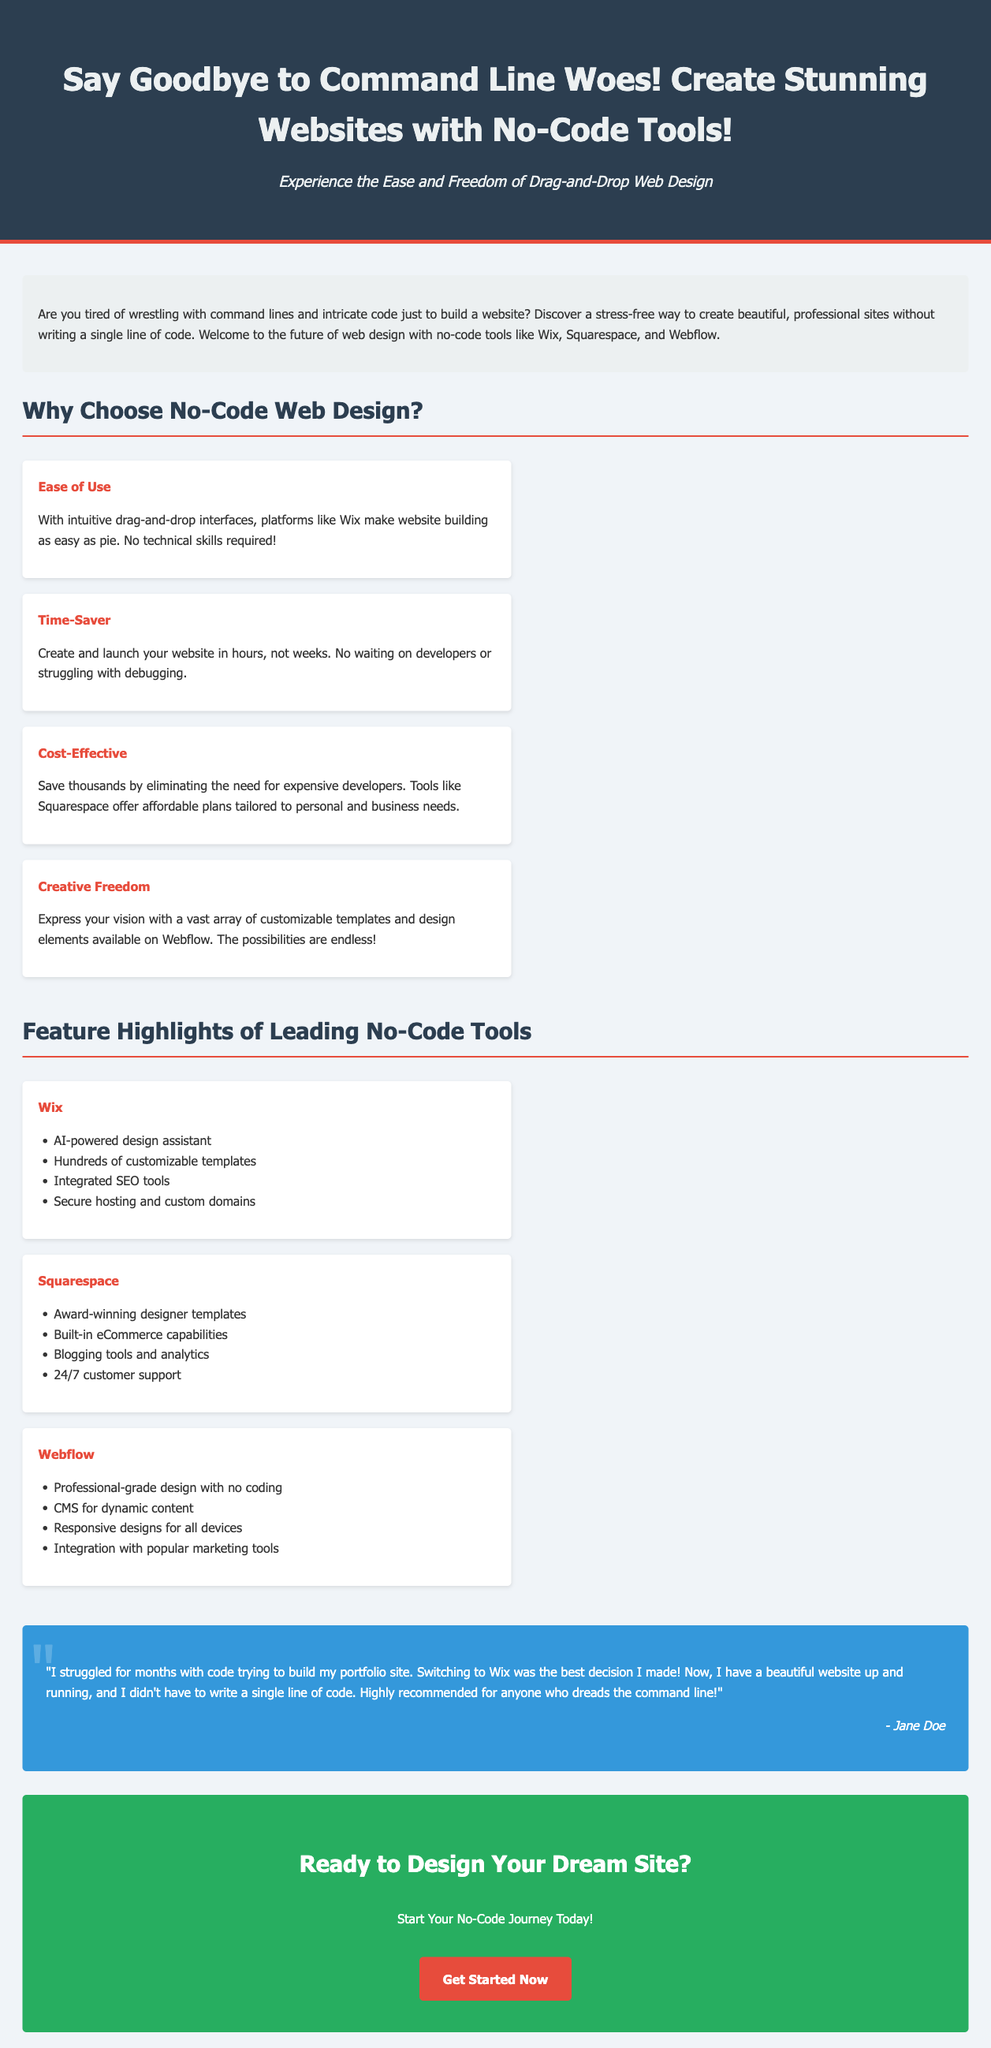What is the target audience for this advertisement? The advertisement is aimed at individuals who want to create websites without using code, emphasizing ease for those who dislike technical challenges.
Answer: Individuals avoiding command lines What is the name of the first no-code tool mentioned? The first no-code tool highlighted in the document is Wix, listed under feature highlights.
Answer: Wix How many benefits of no-code web design are listed? There are four benefits provided in the section titled "Why Choose No-Code Web Design?".
Answer: Four What color is the call-to-action button? The call-to-action button is specified to have a red color scheme, particularly in its hover state.
Answer: Red Who provided the testimonial featured in the document? The testimonial is quoted from a user named Jane Doe, indicating her positive experience with Wix.
Answer: Jane Doe What is the recommended action at the end of the document? The document encourages readers to start their no-code journey immediately, suggesting action by inviting them to click.
Answer: Get Started Now How does the document describe web design tools like Wix? The document emphasizes that no technical skills are required for building websites with tools like Wix due to intuitive interfaces.
Answer: Intuitive drag-and-drop interfaces How does the document characterize the process of creating a website with no-code tools? It describes the process as easy and quick, with the capability to create websites in hours rather than weeks.
Answer: Create and launch your website in hours 